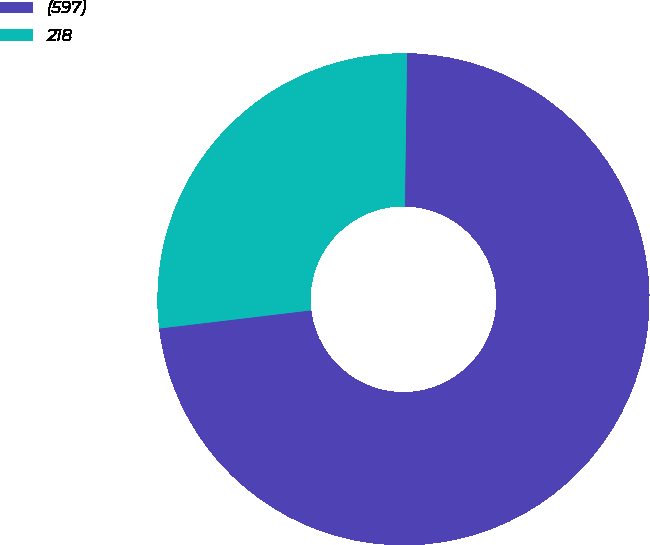Convert chart. <chart><loc_0><loc_0><loc_500><loc_500><pie_chart><fcel>(597)<fcel>218<nl><fcel>72.87%<fcel>27.13%<nl></chart> 